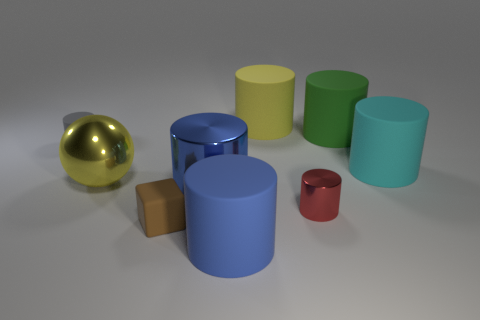Subtract all yellow cylinders. How many cylinders are left? 6 Subtract all small gray cylinders. How many cylinders are left? 6 Subtract all gray cylinders. Subtract all purple spheres. How many cylinders are left? 6 Add 1 big matte things. How many objects exist? 10 Subtract all spheres. How many objects are left? 8 Subtract 0 red spheres. How many objects are left? 9 Subtract all tiny blue metallic things. Subtract all red metal cylinders. How many objects are left? 8 Add 9 big yellow balls. How many big yellow balls are left? 10 Add 1 large brown spheres. How many large brown spheres exist? 1 